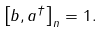<formula> <loc_0><loc_0><loc_500><loc_500>\left [ b , a ^ { \dagger } \right ] _ { n } = 1 .</formula> 